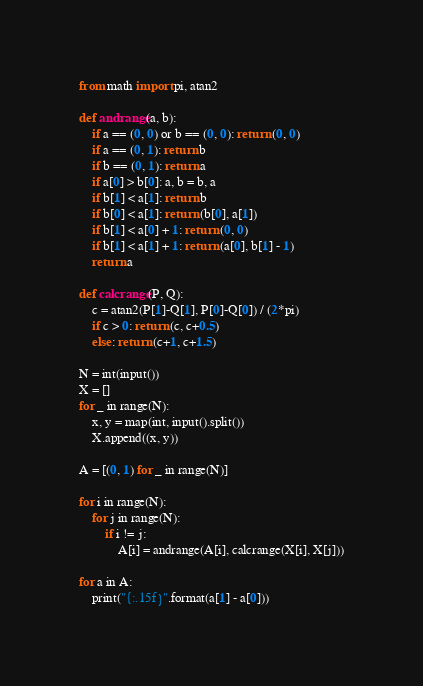Convert code to text. <code><loc_0><loc_0><loc_500><loc_500><_Python_>from math import pi, atan2

def andrange(a, b):
    if a == (0, 0) or b == (0, 0): return (0, 0)
    if a == (0, 1): return b
    if b == (0, 1): return a
    if a[0] > b[0]: a, b = b, a
    if b[1] < a[1]: return b
    if b[0] < a[1]: return (b[0], a[1])
    if b[1] < a[0] + 1: return (0, 0)
    if b[1] < a[1] + 1: return (a[0], b[1] - 1)
    return a

def calcrange(P, Q):
    c = atan2(P[1]-Q[1], P[0]-Q[0]) / (2*pi)
    if c > 0: return (c, c+0.5)
    else: return (c+1, c+1.5)

N = int(input())
X = []
for _ in range(N):
    x, y = map(int, input().split())
    X.append((x, y))

A = [(0, 1) for _ in range(N)]

for i in range(N):
    for j in range(N):
        if i != j:
            A[i] = andrange(A[i], calcrange(X[i], X[j]))

for a in A:
    print("{:.15f}".format(a[1] - a[0]))
</code> 